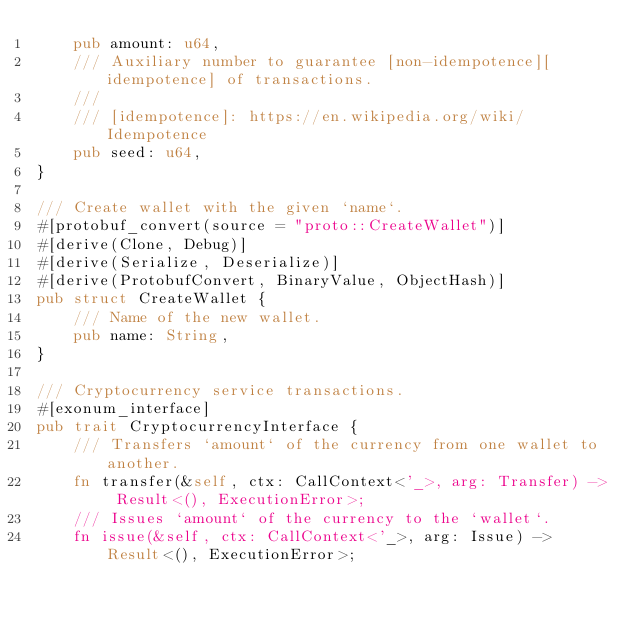<code> <loc_0><loc_0><loc_500><loc_500><_Rust_>    pub amount: u64,
    /// Auxiliary number to guarantee [non-idempotence][idempotence] of transactions.
    ///
    /// [idempotence]: https://en.wikipedia.org/wiki/Idempotence
    pub seed: u64,
}

/// Create wallet with the given `name`.
#[protobuf_convert(source = "proto::CreateWallet")]
#[derive(Clone, Debug)]
#[derive(Serialize, Deserialize)]
#[derive(ProtobufConvert, BinaryValue, ObjectHash)]
pub struct CreateWallet {
    /// Name of the new wallet.
    pub name: String,
}

/// Cryptocurrency service transactions.
#[exonum_interface]
pub trait CryptocurrencyInterface {
    /// Transfers `amount` of the currency from one wallet to another.
    fn transfer(&self, ctx: CallContext<'_>, arg: Transfer) -> Result<(), ExecutionError>;
    /// Issues `amount` of the currency to the `wallet`.
    fn issue(&self, ctx: CallContext<'_>, arg: Issue) -> Result<(), ExecutionError>;</code> 